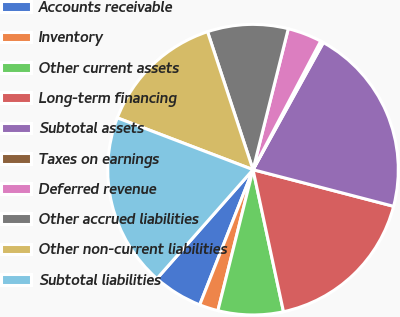<chart> <loc_0><loc_0><loc_500><loc_500><pie_chart><fcel>Accounts receivable<fcel>Inventory<fcel>Other current assets<fcel>Long-term financing<fcel>Subtotal assets<fcel>Taxes on earnings<fcel>Deferred revenue<fcel>Other accrued liabilities<fcel>Other non-current liabilities<fcel>Subtotal liabilities<nl><fcel>5.53%<fcel>2.09%<fcel>7.25%<fcel>17.58%<fcel>21.02%<fcel>0.33%<fcel>3.81%<fcel>8.97%<fcel>14.13%<fcel>19.3%<nl></chart> 